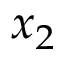Convert formula to latex. <formula><loc_0><loc_0><loc_500><loc_500>x _ { 2 }</formula> 